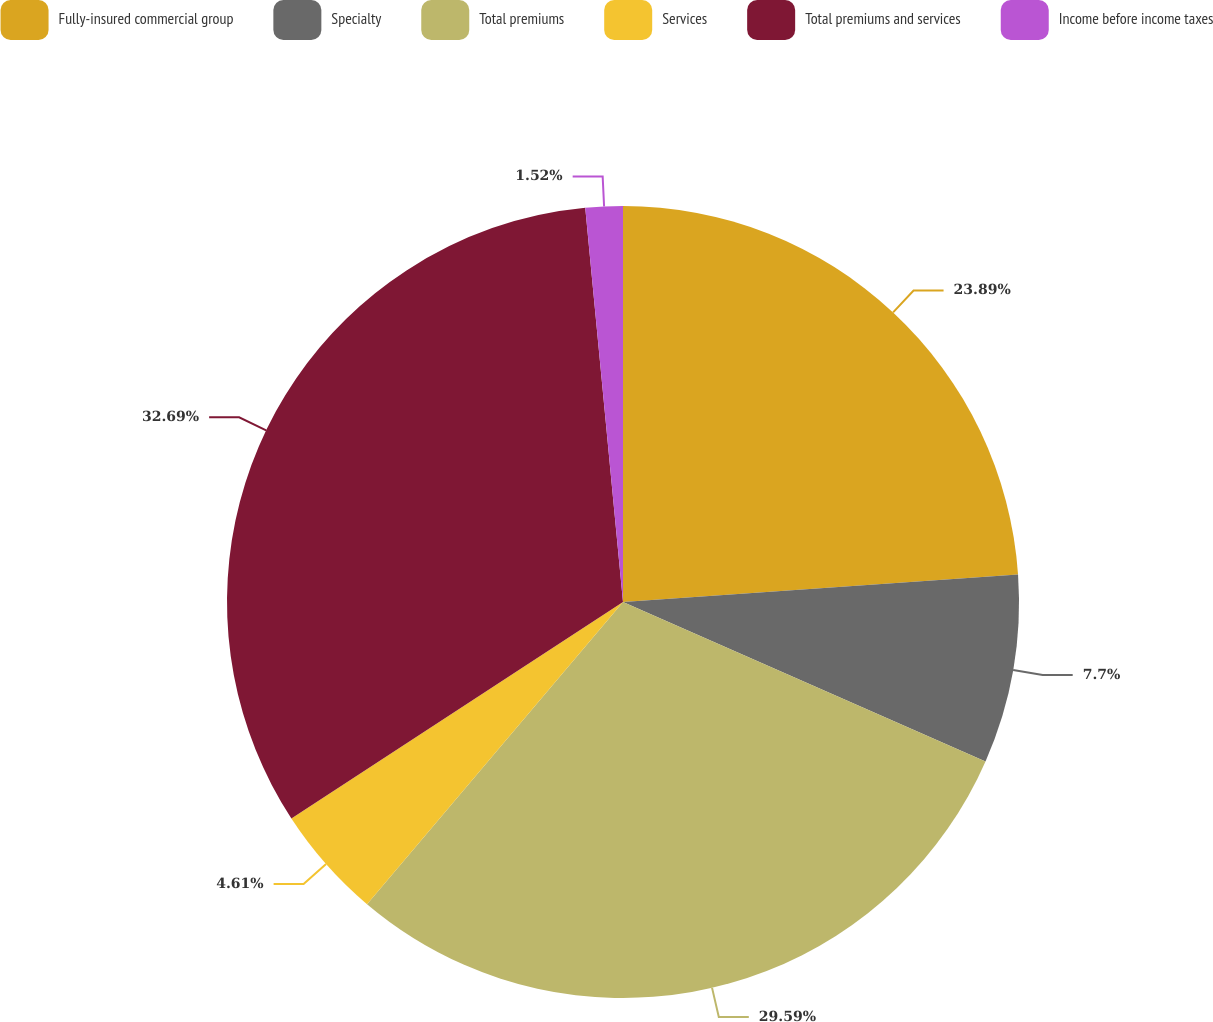Convert chart. <chart><loc_0><loc_0><loc_500><loc_500><pie_chart><fcel>Fully-insured commercial group<fcel>Specialty<fcel>Total premiums<fcel>Services<fcel>Total premiums and services<fcel>Income before income taxes<nl><fcel>23.89%<fcel>7.7%<fcel>29.59%<fcel>4.61%<fcel>32.68%<fcel>1.52%<nl></chart> 